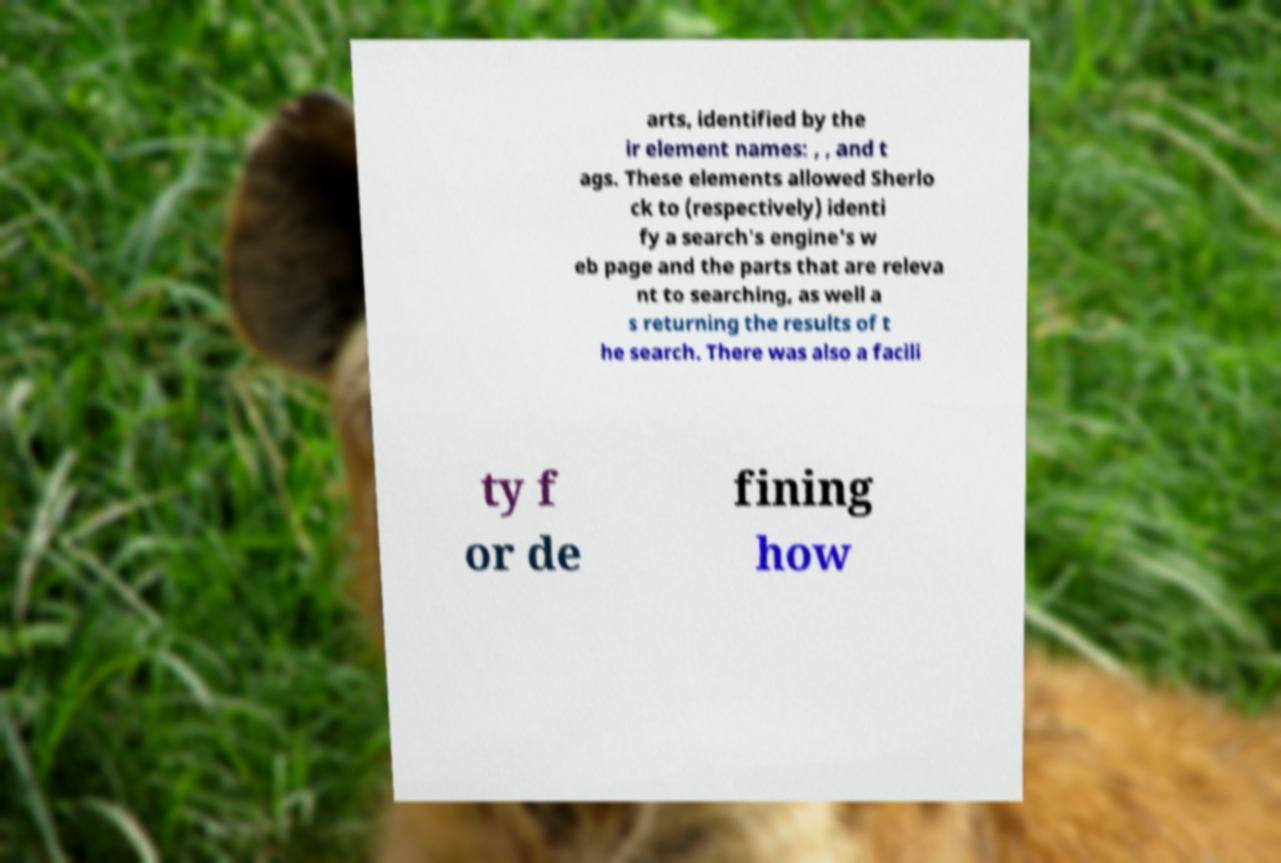Could you extract and type out the text from this image? arts, identified by the ir element names: , , and t ags. These elements allowed Sherlo ck to (respectively) identi fy a search's engine's w eb page and the parts that are releva nt to searching, as well a s returning the results of t he search. There was also a facili ty f or de fining how 